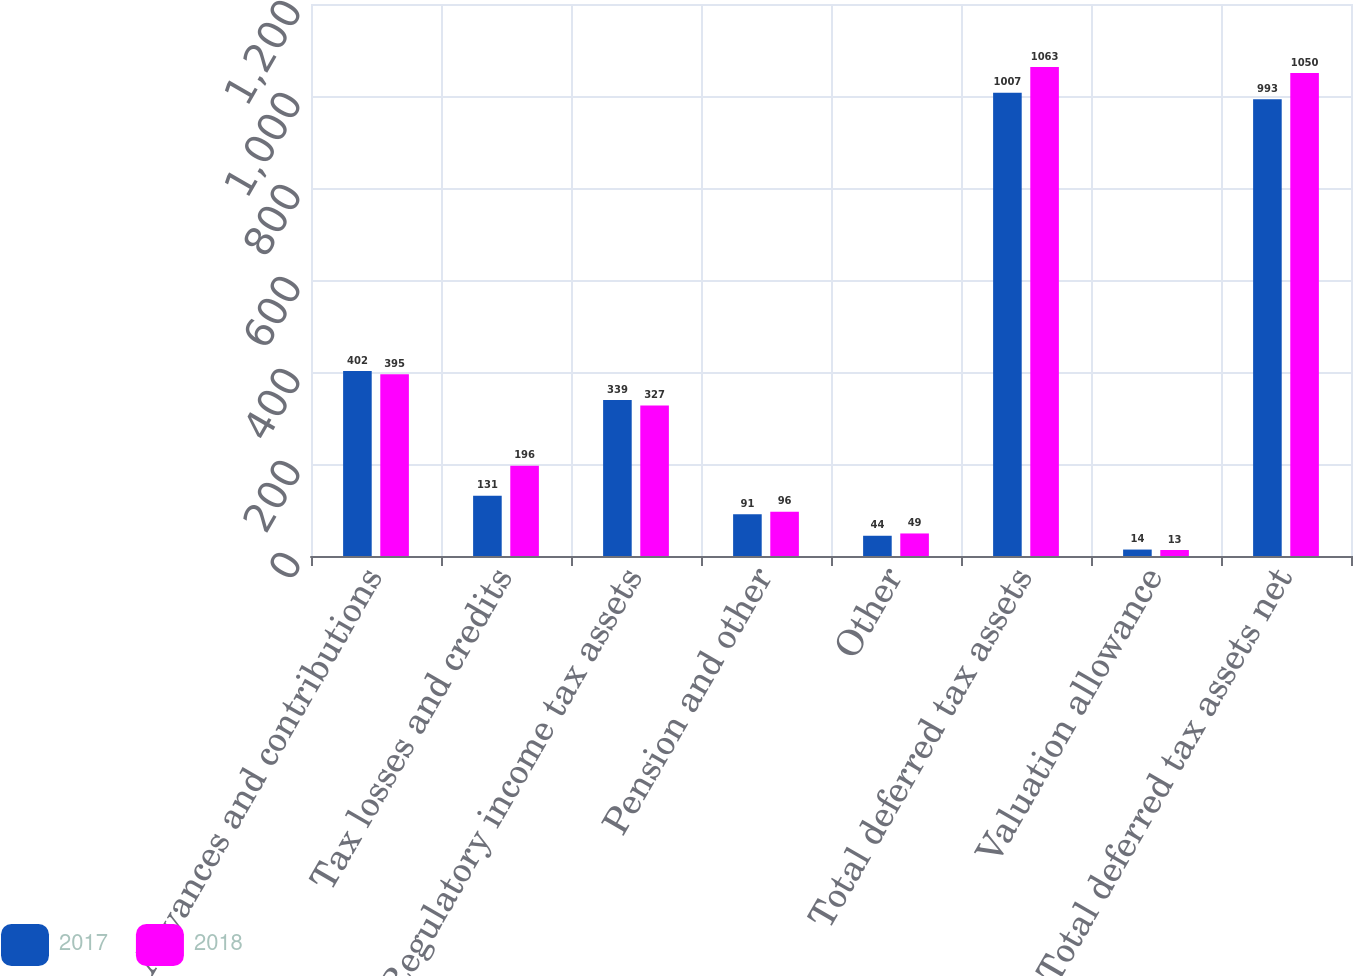Convert chart. <chart><loc_0><loc_0><loc_500><loc_500><stacked_bar_chart><ecel><fcel>Advances and contributions<fcel>Tax losses and credits<fcel>Regulatory income tax assets<fcel>Pension and other<fcel>Other<fcel>Total deferred tax assets<fcel>Valuation allowance<fcel>Total deferred tax assets net<nl><fcel>2017<fcel>402<fcel>131<fcel>339<fcel>91<fcel>44<fcel>1007<fcel>14<fcel>993<nl><fcel>2018<fcel>395<fcel>196<fcel>327<fcel>96<fcel>49<fcel>1063<fcel>13<fcel>1050<nl></chart> 